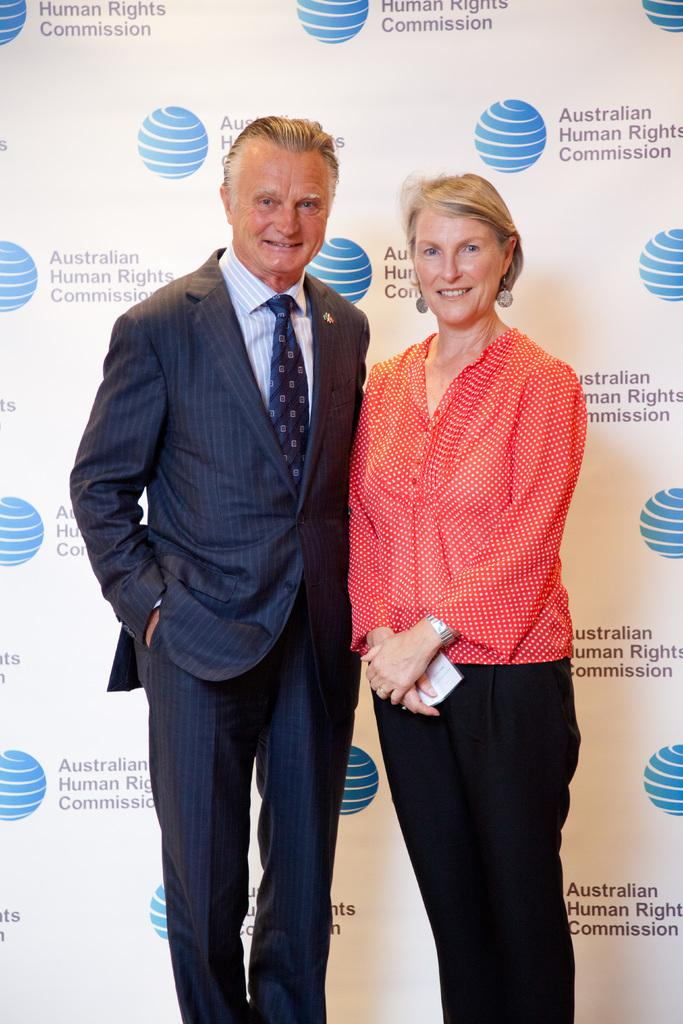How many people are in the image? There are two people standing in the image. What are the people doing in the image? The people are posing for a photo. What can be seen in the background of the image? There is a banner in the background of the image. What is on the banner? The banner has logos of some organization. What color is the sweater worn by the person on the left in the image? There is no information about the color of a sweater or any clothing worn by the people in the image. --- Facts: 1. There is a car in the image. 2. The car is parked on the street. 3. There are trees on both sides of the street. 4. The sky is visible in the image. Absurd Topics: parrot, dance, ocean Conversation: What is the main subject of the image? The main subject of the image is a car. Where is the car located in the image? The car is parked on the street. What can be seen on both sides of the street in the image? There are trees on both sides of the street. What is visible in the background of the image? The sky is visible in the image. Reasoning: Let's think step by step in order to produce the conversation. We start by identifying the main subject in the image, which is the car. Then, we describe the car's location, which is parked on the street. Next, we mention the surrounding environment, which includes trees on both sides of the street. Finally, we describe the background element, which is the sky. Absurd Question/Answer: Can you see a parrot dancing by the ocean in the image? No, there is no parrot, dancing, or ocean present in the image. 